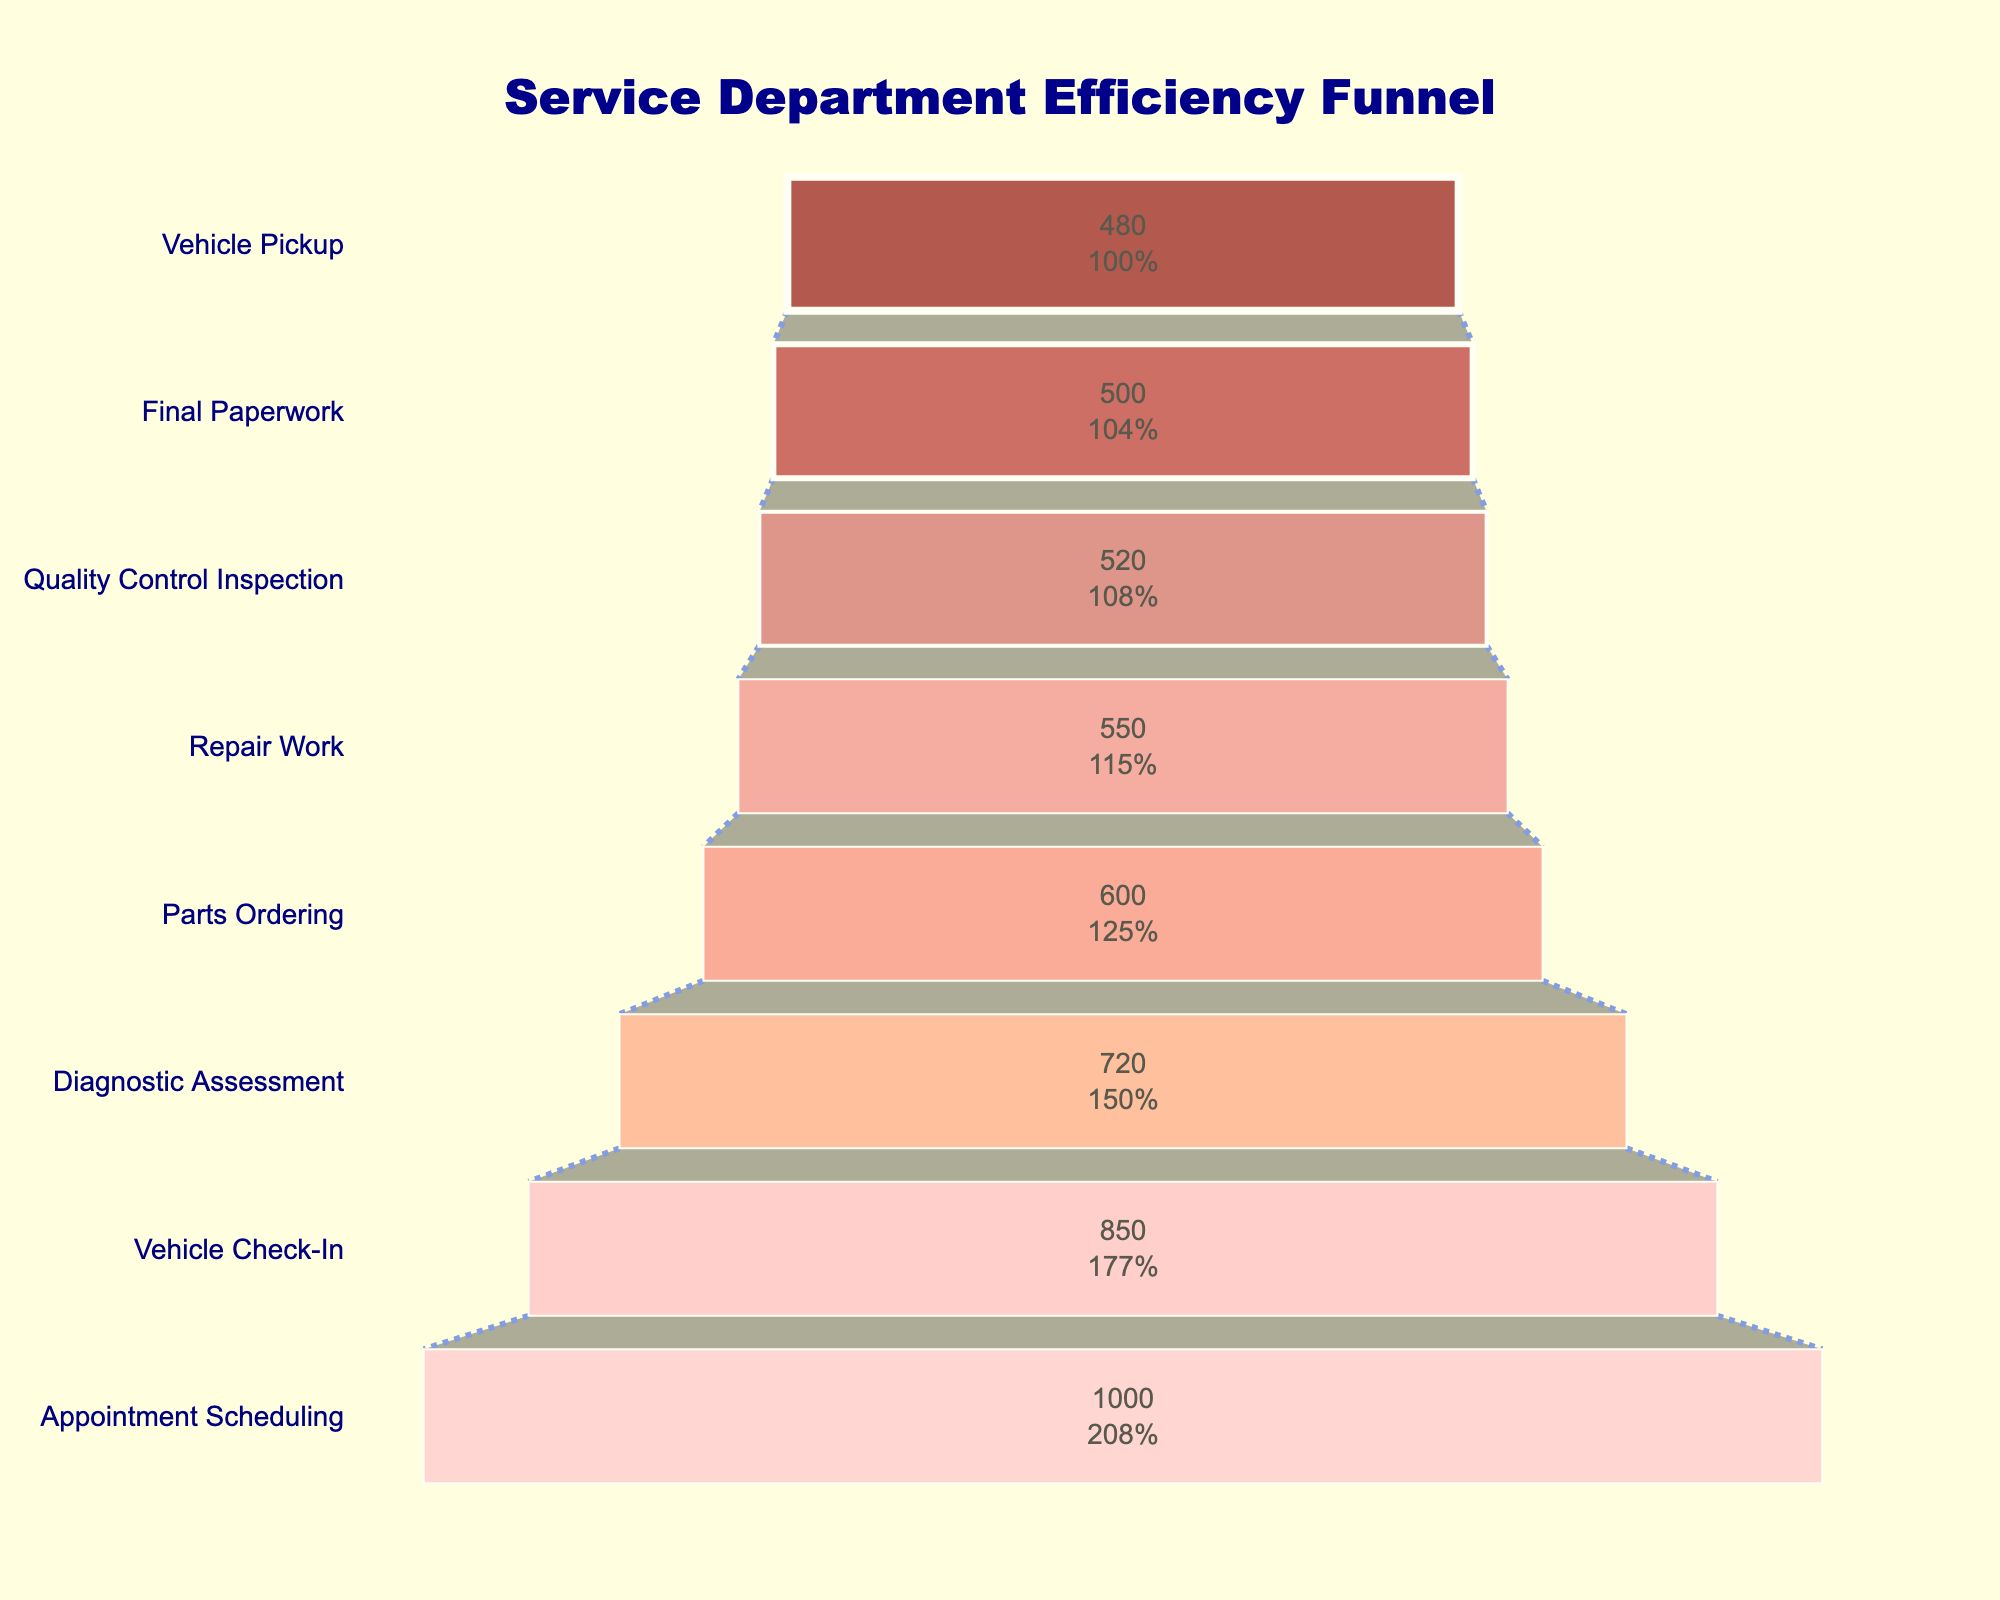what is the title of the chart? The title is usually at the top and in bold text. In this chart, it reads "Service Department Efficiency Funnel".
Answer: Service Department Efficiency Funnel How many stages are there from appointment scheduling to vehicle pickup? Count the number of distinct stages on the y-axis. They are "Appointment Scheduling", "Vehicle Check-In", "Diagnostic Assessment", "Parts Ordering", "Repair Work", "Quality Control Inspection", "Final Paperwork", and "Vehicle Pickup".
Answer: 8 What stage comes immediately before "Parts Ordering"? Look at the y-axis and find the stage that is directly above (which comes before in the process) "Parts Ordering". It is "Diagnostic Assessment".
Answer: Diagnostic Assessment How many customers proceed from the "Vehicle Check-In" stage to the "Diagnostic Assessment" stage? Look at the values on the x-axis for "Vehicle Check-In" and "Diagnostic Assessment". The number of customers at "Vehicle Check-In" is 850, and at "Diagnostic Assessment" it is 720.
Answer: 720 Which stage has the lowest number of customers? Look at the x-axis values of each stage and identify the stage with the smallest number. The "Vehicle Pickup" stage has 480 customers, which is the lowest.
Answer: Vehicle Pickup How many customers are lost between the "Appointment Scheduling" and "Vehicle Check-In" stages? Subtract the number of customers at the "Vehicle Check-In" stage from those at the "Appointment Scheduling" stage: 1000 - 850 = 150.
Answer: 150 What percentage of customers who scheduled an appointment picked up their vehicle? To find the percentage, divide the number of customers at the "Vehicle Pickup" stage by the number at the "Appointment Scheduling" stage and multiply by 100: (480 / 1000) * 100 = 48%.
Answer: 48% Which stage loses the most customers compared to the one immediately before it? Compare the differences in customer numbers between each consecutive stage. The largest drop is from "Diagnostic Assessment" (720) to "Parts Ordering" (600), a loss of 120 customers.
Answer: From Diagnostic Assessment to Parts Ordering What is the total number of customers lost from "Vehicle Check-In" to "Final Paperwork"? Subtract the number of customers at "Final Paperwork" from those at "Vehicle Check-In": 850 - 500 = 350.
Answer: 350 What is the average number of customers across all stages? Sum the number of customers at all stages and divide by the number of stages: (1000 + 850 + 720 + 600 + 550 + 520 + 500 + 480) / 8 = 652.5.
Answer: 652.5 